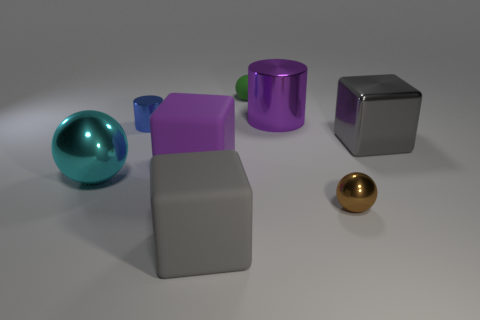The brown metal object that is the same size as the green thing is what shape?
Your response must be concise. Sphere. How many things are big metal things or purple objects to the left of the small green thing?
Your answer should be compact. 4. Do the brown thing that is in front of the large purple rubber object and the tiny ball behind the small blue shiny cylinder have the same material?
Make the answer very short. No. What shape is the big rubber object that is the same color as the large cylinder?
Your answer should be very brief. Cube. How many gray things are small balls or tiny metallic objects?
Your answer should be very brief. 0. How big is the cyan object?
Your answer should be very brief. Large. Is the number of small metallic objects to the right of the tiny blue cylinder greater than the number of tiny green rubber objects?
Ensure brevity in your answer.  No. There is a small blue thing; what number of small cylinders are right of it?
Ensure brevity in your answer.  0. Is there a metallic cylinder of the same size as the gray shiny cube?
Keep it short and to the point. Yes. What color is the small metal object that is the same shape as the big purple shiny thing?
Make the answer very short. Blue. 